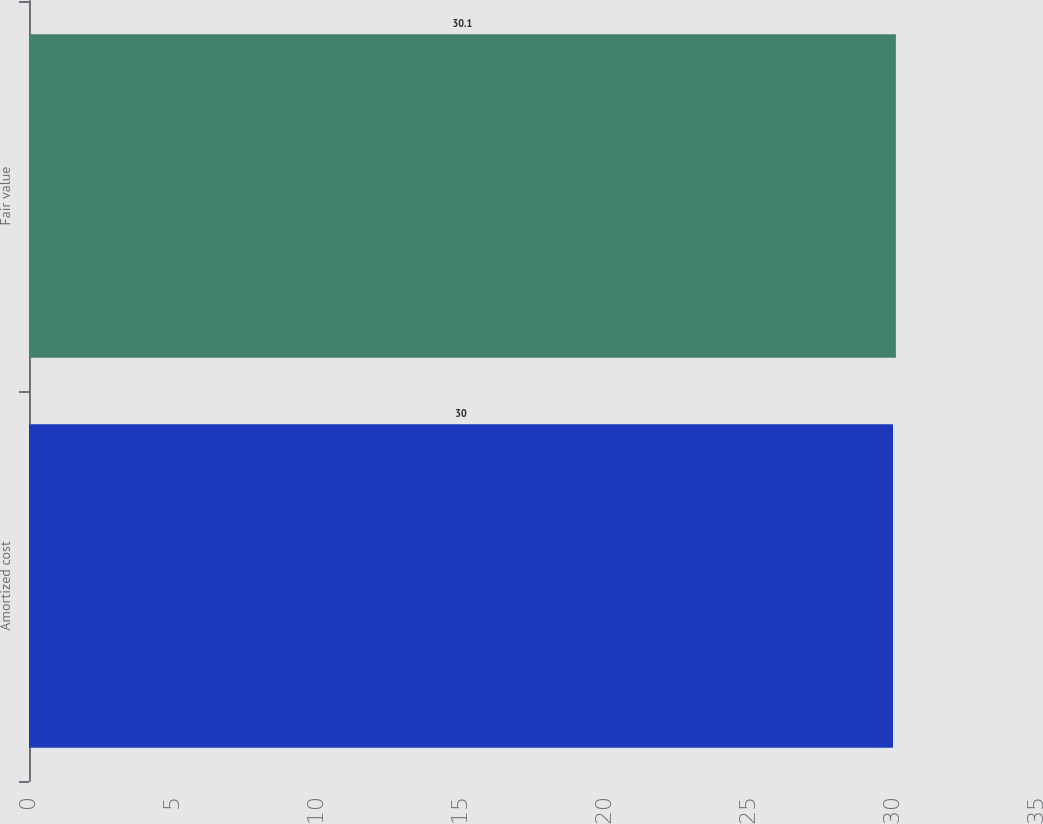Convert chart. <chart><loc_0><loc_0><loc_500><loc_500><bar_chart><fcel>Amortized cost<fcel>Fair value<nl><fcel>30<fcel>30.1<nl></chart> 